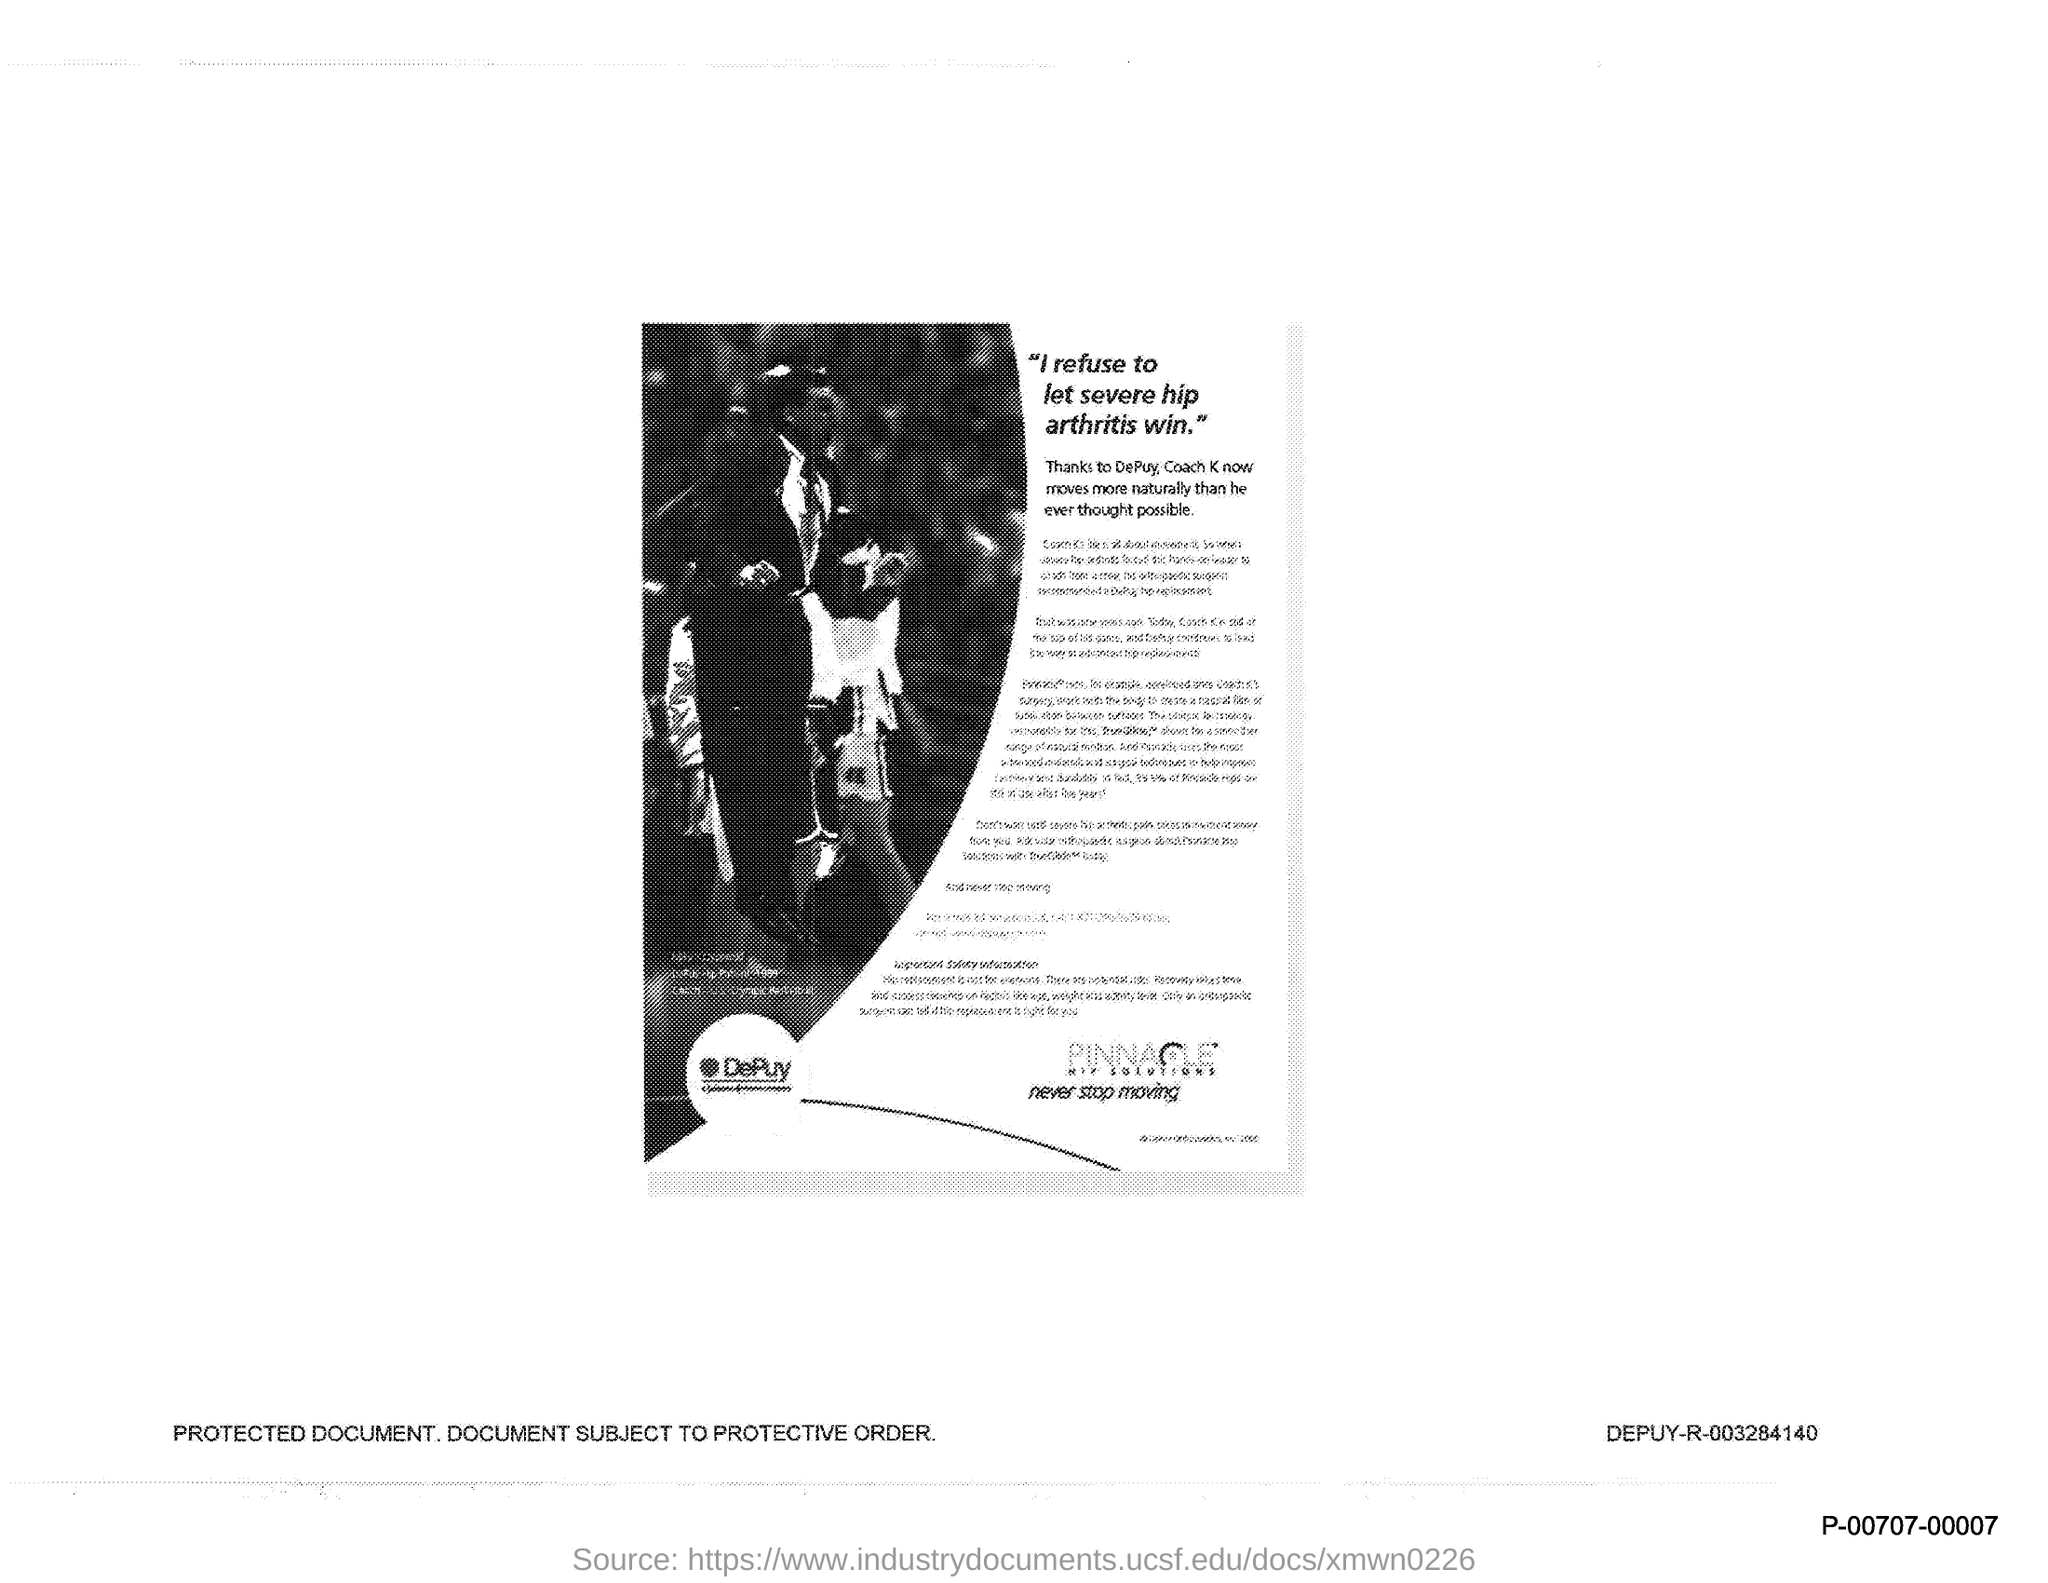What is the title of the document?
Keep it short and to the point. "I refuse to let severe hip arthritis win". 